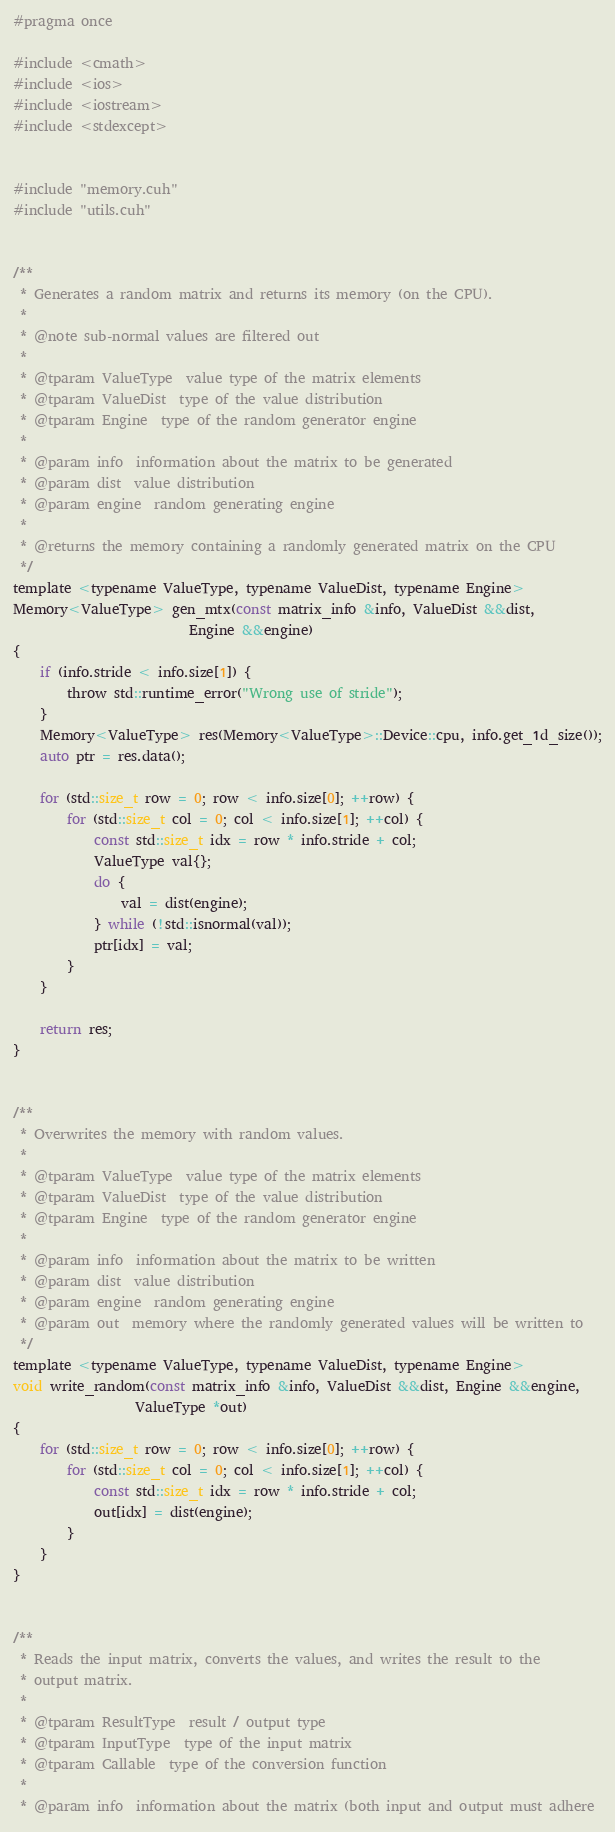<code> <loc_0><loc_0><loc_500><loc_500><_Cuda_>#pragma once

#include <cmath>
#include <ios>
#include <iostream>
#include <stdexcept>


#include "memory.cuh"
#include "utils.cuh"


/**
 * Generates a random matrix and returns its memory (on the CPU).
 *
 * @note sub-normal values are filtered out
 *
 * @tparam ValueType  value type of the matrix elements
 * @tparam ValueDist  type of the value distribution
 * @tparam Engine  type of the random generator engine
 *
 * @param info  information about the matrix to be generated
 * @param dist  value distribution
 * @param engine  random generating engine
 *
 * @returns the memory containing a randomly generated matrix on the CPU
 */
template <typename ValueType, typename ValueDist, typename Engine>
Memory<ValueType> gen_mtx(const matrix_info &info, ValueDist &&dist,
                          Engine &&engine)
{
    if (info.stride < info.size[1]) {
        throw std::runtime_error("Wrong use of stride");
    }
    Memory<ValueType> res(Memory<ValueType>::Device::cpu, info.get_1d_size());
    auto ptr = res.data();

    for (std::size_t row = 0; row < info.size[0]; ++row) {
        for (std::size_t col = 0; col < info.size[1]; ++col) {
            const std::size_t idx = row * info.stride + col;
            ValueType val{};
            do {
                val = dist(engine);
            } while (!std::isnormal(val));
            ptr[idx] = val;
        }
    }

    return res;
}


/**
 * Overwrites the memory with random values.
 *
 * @tparam ValueType  value type of the matrix elements
 * @tparam ValueDist  type of the value distribution
 * @tparam Engine  type of the random generator engine
 *
 * @param info  information about the matrix to be written
 * @param dist  value distribution
 * @param engine  random generating engine
 * @param out  memory where the randomly generated values will be written to
 */
template <typename ValueType, typename ValueDist, typename Engine>
void write_random(const matrix_info &info, ValueDist &&dist, Engine &&engine,
                  ValueType *out)
{
    for (std::size_t row = 0; row < info.size[0]; ++row) {
        for (std::size_t col = 0; col < info.size[1]; ++col) {
            const std::size_t idx = row * info.stride + col;
            out[idx] = dist(engine);
        }
    }
}


/**
 * Reads the input matrix, converts the values, and writes the result to the
 * output matrix.
 *
 * @tparam ResultType  result / output type
 * @tparam InputType  type of the input matrix
 * @tparam Callable  type of the conversion function
 *
 * @param info  information about the matrix (both input and output must adhere</code> 